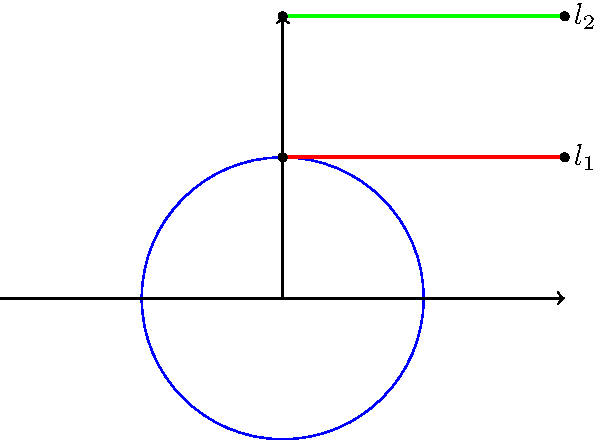In the Poincaré half-plane model of hyperbolic geometry, two lines $l_1$ and $l_2$ are shown. If these lines represent the mesmerizing light beams often seen in Mylène Farmer's concert productions, how would you describe their relationship in this Non-Euclidean space, and what does this imply about their intersection? To understand the relationship between lines $l_1$ and $l_2$ in the Poincaré half-plane model, we need to follow these steps:

1. Recall that in the Poincaré half-plane model, "lines" are represented by either vertical line segments or semicircles perpendicular to the x-axis.

2. Observe that $l_1$ and $l_2$ are both horizontal line segments in the Euclidean plane.

3. In the Poincaré half-plane model, these horizontal line segments actually represent semicircles with centers on the x-axis (which is not shown in the image, but would be below the visible part of the plane).

4. The semicircles representing $l_1$ and $l_2$ would extend beyond the visible part of the diagram, eventually intersecting the x-axis at two points each.

5. In hyperbolic geometry, parallel lines are defined as lines that never intersect.

6. Since the semicircles representing $l_1$ and $l_2$ would intersect the x-axis at different points, they do not intersect each other within the Poincaré half-plane.

7. Therefore, $l_1$ and $l_2$ are parallel lines in this hyperbolic geometry model.

8. This parallelism in the Poincaré half-plane model creates an illusion of convergence at infinity, similar to the way parallel light beams in Mylène Farmer's concerts might appear to converge in the distance, creating a sense of depth and ethereal atmosphere.
Answer: Parallel lines that never intersect 